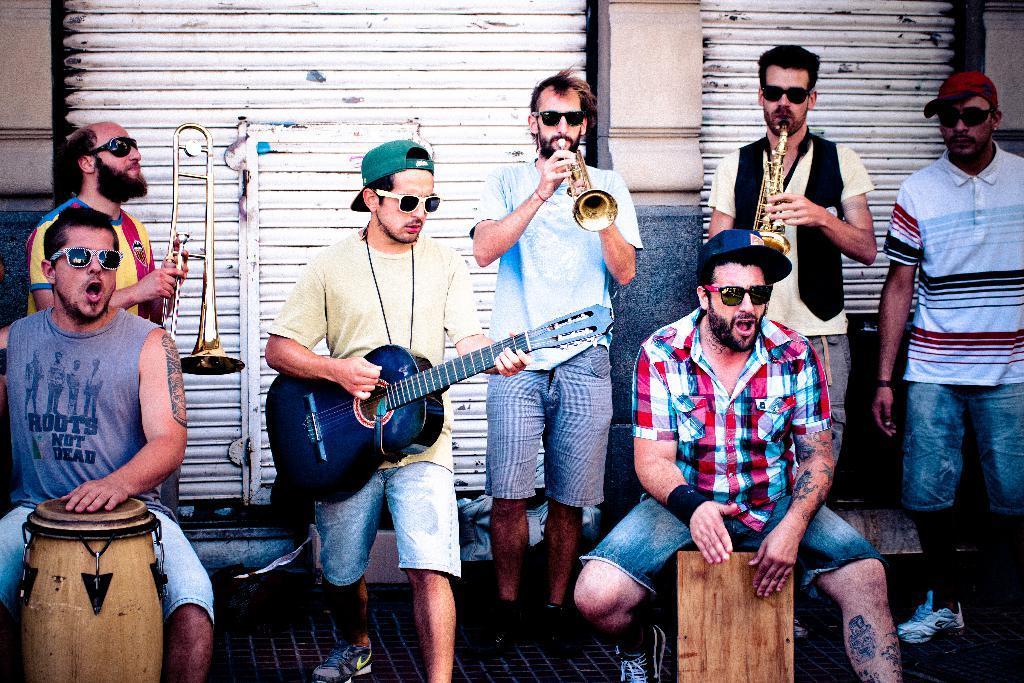Can you describe this image briefly? there are persons in which they are playing some musical instruments 